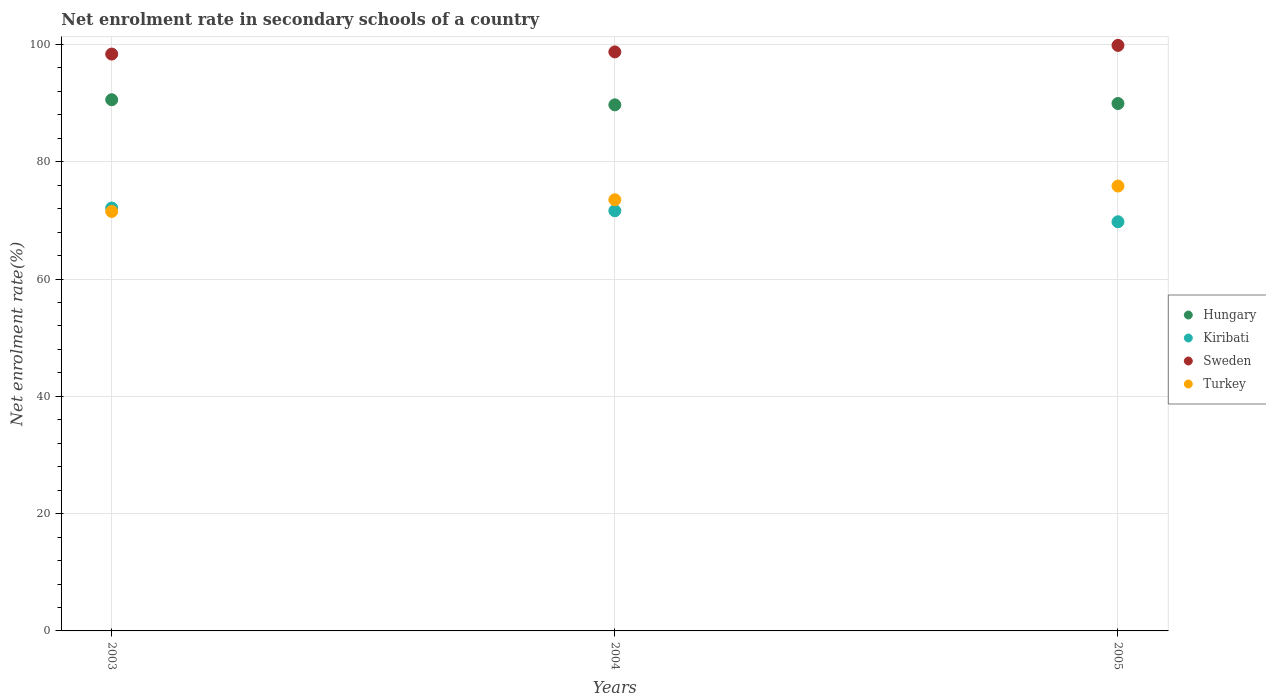How many different coloured dotlines are there?
Ensure brevity in your answer.  4. What is the net enrolment rate in secondary schools in Turkey in 2004?
Offer a very short reply. 73.52. Across all years, what is the maximum net enrolment rate in secondary schools in Turkey?
Your answer should be compact. 75.85. Across all years, what is the minimum net enrolment rate in secondary schools in Turkey?
Your answer should be compact. 71.53. What is the total net enrolment rate in secondary schools in Turkey in the graph?
Your answer should be compact. 220.9. What is the difference between the net enrolment rate in secondary schools in Sweden in 2003 and that in 2005?
Your answer should be very brief. -1.48. What is the difference between the net enrolment rate in secondary schools in Hungary in 2004 and the net enrolment rate in secondary schools in Kiribati in 2003?
Keep it short and to the point. 17.59. What is the average net enrolment rate in secondary schools in Hungary per year?
Provide a succinct answer. 90.07. In the year 2004, what is the difference between the net enrolment rate in secondary schools in Turkey and net enrolment rate in secondary schools in Sweden?
Your answer should be very brief. -25.21. What is the ratio of the net enrolment rate in secondary schools in Hungary in 2003 to that in 2005?
Provide a short and direct response. 1.01. Is the net enrolment rate in secondary schools in Kiribati in 2003 less than that in 2005?
Provide a short and direct response. No. Is the difference between the net enrolment rate in secondary schools in Turkey in 2003 and 2004 greater than the difference between the net enrolment rate in secondary schools in Sweden in 2003 and 2004?
Provide a succinct answer. No. What is the difference between the highest and the second highest net enrolment rate in secondary schools in Sweden?
Give a very brief answer. 1.11. What is the difference between the highest and the lowest net enrolment rate in secondary schools in Kiribati?
Your answer should be very brief. 2.35. In how many years, is the net enrolment rate in secondary schools in Turkey greater than the average net enrolment rate in secondary schools in Turkey taken over all years?
Offer a very short reply. 1. Is it the case that in every year, the sum of the net enrolment rate in secondary schools in Kiribati and net enrolment rate in secondary schools in Hungary  is greater than the sum of net enrolment rate in secondary schools in Turkey and net enrolment rate in secondary schools in Sweden?
Make the answer very short. No. Does the net enrolment rate in secondary schools in Hungary monotonically increase over the years?
Give a very brief answer. No. How many dotlines are there?
Your response must be concise. 4. What is the difference between two consecutive major ticks on the Y-axis?
Keep it short and to the point. 20. Are the values on the major ticks of Y-axis written in scientific E-notation?
Offer a terse response. No. Does the graph contain grids?
Keep it short and to the point. Yes. Where does the legend appear in the graph?
Your answer should be compact. Center right. How are the legend labels stacked?
Give a very brief answer. Vertical. What is the title of the graph?
Offer a terse response. Net enrolment rate in secondary schools of a country. Does "Slovenia" appear as one of the legend labels in the graph?
Your response must be concise. No. What is the label or title of the X-axis?
Offer a terse response. Years. What is the label or title of the Y-axis?
Offer a terse response. Net enrolment rate(%). What is the Net enrolment rate(%) of Hungary in 2003?
Give a very brief answer. 90.57. What is the Net enrolment rate(%) of Kiribati in 2003?
Keep it short and to the point. 72.11. What is the Net enrolment rate(%) in Sweden in 2003?
Your answer should be compact. 98.36. What is the Net enrolment rate(%) of Turkey in 2003?
Provide a succinct answer. 71.53. What is the Net enrolment rate(%) of Hungary in 2004?
Provide a short and direct response. 89.7. What is the Net enrolment rate(%) of Kiribati in 2004?
Give a very brief answer. 71.64. What is the Net enrolment rate(%) of Sweden in 2004?
Offer a very short reply. 98.73. What is the Net enrolment rate(%) in Turkey in 2004?
Give a very brief answer. 73.52. What is the Net enrolment rate(%) of Hungary in 2005?
Provide a short and direct response. 89.93. What is the Net enrolment rate(%) in Kiribati in 2005?
Ensure brevity in your answer.  69.76. What is the Net enrolment rate(%) of Sweden in 2005?
Provide a succinct answer. 99.84. What is the Net enrolment rate(%) in Turkey in 2005?
Ensure brevity in your answer.  75.85. Across all years, what is the maximum Net enrolment rate(%) in Hungary?
Give a very brief answer. 90.57. Across all years, what is the maximum Net enrolment rate(%) in Kiribati?
Your answer should be very brief. 72.11. Across all years, what is the maximum Net enrolment rate(%) in Sweden?
Provide a short and direct response. 99.84. Across all years, what is the maximum Net enrolment rate(%) in Turkey?
Your answer should be very brief. 75.85. Across all years, what is the minimum Net enrolment rate(%) of Hungary?
Give a very brief answer. 89.7. Across all years, what is the minimum Net enrolment rate(%) of Kiribati?
Provide a short and direct response. 69.76. Across all years, what is the minimum Net enrolment rate(%) of Sweden?
Provide a succinct answer. 98.36. Across all years, what is the minimum Net enrolment rate(%) of Turkey?
Make the answer very short. 71.53. What is the total Net enrolment rate(%) of Hungary in the graph?
Provide a short and direct response. 270.2. What is the total Net enrolment rate(%) in Kiribati in the graph?
Offer a very short reply. 213.51. What is the total Net enrolment rate(%) of Sweden in the graph?
Make the answer very short. 296.92. What is the total Net enrolment rate(%) of Turkey in the graph?
Provide a succinct answer. 220.9. What is the difference between the Net enrolment rate(%) in Hungary in 2003 and that in 2004?
Make the answer very short. 0.87. What is the difference between the Net enrolment rate(%) of Kiribati in 2003 and that in 2004?
Offer a very short reply. 0.47. What is the difference between the Net enrolment rate(%) in Sweden in 2003 and that in 2004?
Ensure brevity in your answer.  -0.37. What is the difference between the Net enrolment rate(%) in Turkey in 2003 and that in 2004?
Offer a terse response. -1.99. What is the difference between the Net enrolment rate(%) of Hungary in 2003 and that in 2005?
Provide a succinct answer. 0.64. What is the difference between the Net enrolment rate(%) of Kiribati in 2003 and that in 2005?
Offer a terse response. 2.35. What is the difference between the Net enrolment rate(%) of Sweden in 2003 and that in 2005?
Provide a succinct answer. -1.48. What is the difference between the Net enrolment rate(%) in Turkey in 2003 and that in 2005?
Ensure brevity in your answer.  -4.33. What is the difference between the Net enrolment rate(%) in Hungary in 2004 and that in 2005?
Offer a terse response. -0.23. What is the difference between the Net enrolment rate(%) of Kiribati in 2004 and that in 2005?
Offer a terse response. 1.88. What is the difference between the Net enrolment rate(%) of Sweden in 2004 and that in 2005?
Make the answer very short. -1.11. What is the difference between the Net enrolment rate(%) in Turkey in 2004 and that in 2005?
Make the answer very short. -2.34. What is the difference between the Net enrolment rate(%) in Hungary in 2003 and the Net enrolment rate(%) in Kiribati in 2004?
Your answer should be compact. 18.93. What is the difference between the Net enrolment rate(%) in Hungary in 2003 and the Net enrolment rate(%) in Sweden in 2004?
Ensure brevity in your answer.  -8.15. What is the difference between the Net enrolment rate(%) of Hungary in 2003 and the Net enrolment rate(%) of Turkey in 2004?
Offer a terse response. 17.06. What is the difference between the Net enrolment rate(%) in Kiribati in 2003 and the Net enrolment rate(%) in Sweden in 2004?
Your answer should be very brief. -26.62. What is the difference between the Net enrolment rate(%) in Kiribati in 2003 and the Net enrolment rate(%) in Turkey in 2004?
Your response must be concise. -1.41. What is the difference between the Net enrolment rate(%) of Sweden in 2003 and the Net enrolment rate(%) of Turkey in 2004?
Your answer should be very brief. 24.84. What is the difference between the Net enrolment rate(%) of Hungary in 2003 and the Net enrolment rate(%) of Kiribati in 2005?
Your response must be concise. 20.81. What is the difference between the Net enrolment rate(%) in Hungary in 2003 and the Net enrolment rate(%) in Sweden in 2005?
Your answer should be compact. -9.26. What is the difference between the Net enrolment rate(%) in Hungary in 2003 and the Net enrolment rate(%) in Turkey in 2005?
Provide a succinct answer. 14.72. What is the difference between the Net enrolment rate(%) in Kiribati in 2003 and the Net enrolment rate(%) in Sweden in 2005?
Ensure brevity in your answer.  -27.73. What is the difference between the Net enrolment rate(%) of Kiribati in 2003 and the Net enrolment rate(%) of Turkey in 2005?
Keep it short and to the point. -3.75. What is the difference between the Net enrolment rate(%) in Sweden in 2003 and the Net enrolment rate(%) in Turkey in 2005?
Provide a succinct answer. 22.5. What is the difference between the Net enrolment rate(%) in Hungary in 2004 and the Net enrolment rate(%) in Kiribati in 2005?
Your answer should be very brief. 19.94. What is the difference between the Net enrolment rate(%) in Hungary in 2004 and the Net enrolment rate(%) in Sweden in 2005?
Provide a short and direct response. -10.14. What is the difference between the Net enrolment rate(%) in Hungary in 2004 and the Net enrolment rate(%) in Turkey in 2005?
Give a very brief answer. 13.85. What is the difference between the Net enrolment rate(%) of Kiribati in 2004 and the Net enrolment rate(%) of Sweden in 2005?
Provide a short and direct response. -28.2. What is the difference between the Net enrolment rate(%) in Kiribati in 2004 and the Net enrolment rate(%) in Turkey in 2005?
Your answer should be very brief. -4.21. What is the difference between the Net enrolment rate(%) in Sweden in 2004 and the Net enrolment rate(%) in Turkey in 2005?
Give a very brief answer. 22.87. What is the average Net enrolment rate(%) in Hungary per year?
Offer a very short reply. 90.07. What is the average Net enrolment rate(%) in Kiribati per year?
Provide a succinct answer. 71.17. What is the average Net enrolment rate(%) in Sweden per year?
Ensure brevity in your answer.  98.97. What is the average Net enrolment rate(%) of Turkey per year?
Offer a very short reply. 73.63. In the year 2003, what is the difference between the Net enrolment rate(%) in Hungary and Net enrolment rate(%) in Kiribati?
Offer a terse response. 18.46. In the year 2003, what is the difference between the Net enrolment rate(%) in Hungary and Net enrolment rate(%) in Sweden?
Provide a succinct answer. -7.79. In the year 2003, what is the difference between the Net enrolment rate(%) of Hungary and Net enrolment rate(%) of Turkey?
Offer a terse response. 19.05. In the year 2003, what is the difference between the Net enrolment rate(%) in Kiribati and Net enrolment rate(%) in Sweden?
Keep it short and to the point. -26.25. In the year 2003, what is the difference between the Net enrolment rate(%) in Kiribati and Net enrolment rate(%) in Turkey?
Your answer should be very brief. 0.58. In the year 2003, what is the difference between the Net enrolment rate(%) of Sweden and Net enrolment rate(%) of Turkey?
Your answer should be compact. 26.83. In the year 2004, what is the difference between the Net enrolment rate(%) of Hungary and Net enrolment rate(%) of Kiribati?
Give a very brief answer. 18.06. In the year 2004, what is the difference between the Net enrolment rate(%) in Hungary and Net enrolment rate(%) in Sweden?
Offer a very short reply. -9.03. In the year 2004, what is the difference between the Net enrolment rate(%) in Hungary and Net enrolment rate(%) in Turkey?
Provide a short and direct response. 16.18. In the year 2004, what is the difference between the Net enrolment rate(%) of Kiribati and Net enrolment rate(%) of Sweden?
Make the answer very short. -27.09. In the year 2004, what is the difference between the Net enrolment rate(%) in Kiribati and Net enrolment rate(%) in Turkey?
Your answer should be very brief. -1.88. In the year 2004, what is the difference between the Net enrolment rate(%) in Sweden and Net enrolment rate(%) in Turkey?
Keep it short and to the point. 25.21. In the year 2005, what is the difference between the Net enrolment rate(%) in Hungary and Net enrolment rate(%) in Kiribati?
Your answer should be compact. 20.17. In the year 2005, what is the difference between the Net enrolment rate(%) in Hungary and Net enrolment rate(%) in Sweden?
Offer a terse response. -9.91. In the year 2005, what is the difference between the Net enrolment rate(%) in Hungary and Net enrolment rate(%) in Turkey?
Make the answer very short. 14.07. In the year 2005, what is the difference between the Net enrolment rate(%) in Kiribati and Net enrolment rate(%) in Sweden?
Give a very brief answer. -30.07. In the year 2005, what is the difference between the Net enrolment rate(%) in Kiribati and Net enrolment rate(%) in Turkey?
Keep it short and to the point. -6.09. In the year 2005, what is the difference between the Net enrolment rate(%) of Sweden and Net enrolment rate(%) of Turkey?
Offer a very short reply. 23.98. What is the ratio of the Net enrolment rate(%) in Hungary in 2003 to that in 2004?
Provide a short and direct response. 1.01. What is the ratio of the Net enrolment rate(%) of Sweden in 2003 to that in 2004?
Your response must be concise. 1. What is the ratio of the Net enrolment rate(%) in Turkey in 2003 to that in 2004?
Offer a terse response. 0.97. What is the ratio of the Net enrolment rate(%) in Kiribati in 2003 to that in 2005?
Offer a very short reply. 1.03. What is the ratio of the Net enrolment rate(%) in Sweden in 2003 to that in 2005?
Offer a terse response. 0.99. What is the ratio of the Net enrolment rate(%) of Turkey in 2003 to that in 2005?
Your answer should be compact. 0.94. What is the ratio of the Net enrolment rate(%) of Kiribati in 2004 to that in 2005?
Make the answer very short. 1.03. What is the ratio of the Net enrolment rate(%) in Sweden in 2004 to that in 2005?
Make the answer very short. 0.99. What is the ratio of the Net enrolment rate(%) in Turkey in 2004 to that in 2005?
Offer a very short reply. 0.97. What is the difference between the highest and the second highest Net enrolment rate(%) of Hungary?
Give a very brief answer. 0.64. What is the difference between the highest and the second highest Net enrolment rate(%) of Kiribati?
Provide a succinct answer. 0.47. What is the difference between the highest and the second highest Net enrolment rate(%) in Sweden?
Your answer should be compact. 1.11. What is the difference between the highest and the second highest Net enrolment rate(%) in Turkey?
Offer a terse response. 2.34. What is the difference between the highest and the lowest Net enrolment rate(%) of Hungary?
Provide a short and direct response. 0.87. What is the difference between the highest and the lowest Net enrolment rate(%) of Kiribati?
Keep it short and to the point. 2.35. What is the difference between the highest and the lowest Net enrolment rate(%) of Sweden?
Offer a terse response. 1.48. What is the difference between the highest and the lowest Net enrolment rate(%) of Turkey?
Keep it short and to the point. 4.33. 